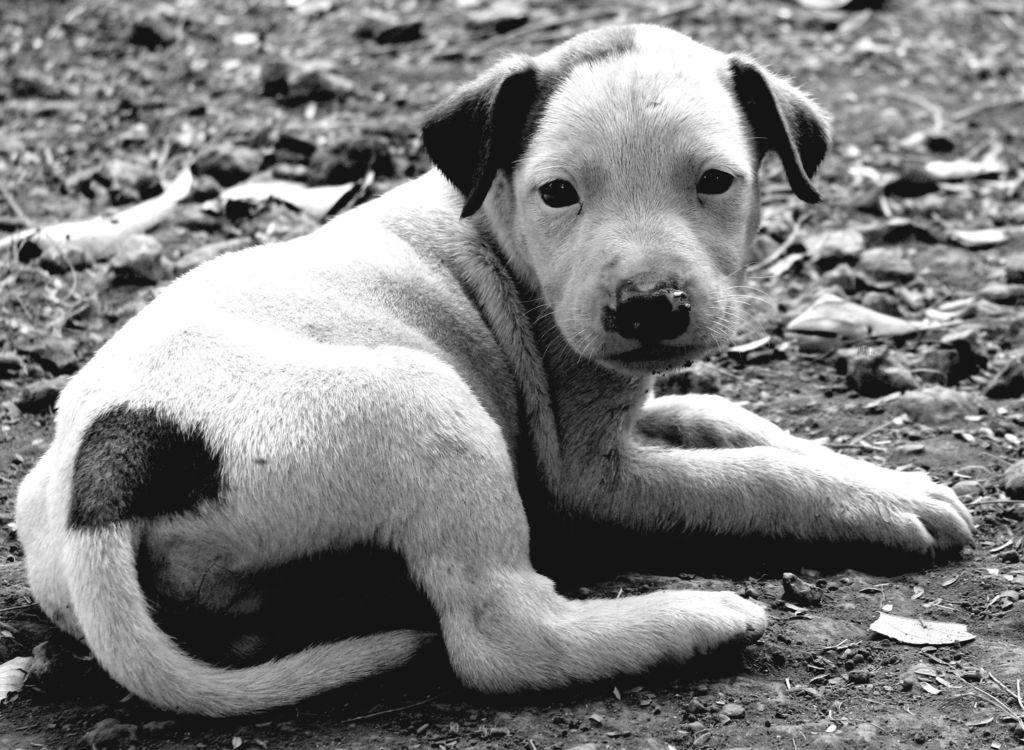What animal is present in the image? There is a dog in the image. What is the dog doing in the image? The dog is laying on the ground. What type of sail is the dog using to navigate the ocean in the image? There is no sail or ocean present in the image; it features a dog laying on the ground. What type of writing can be seen on the dog's collar in the image? There is no collar or writing visible on the dog in the image. 